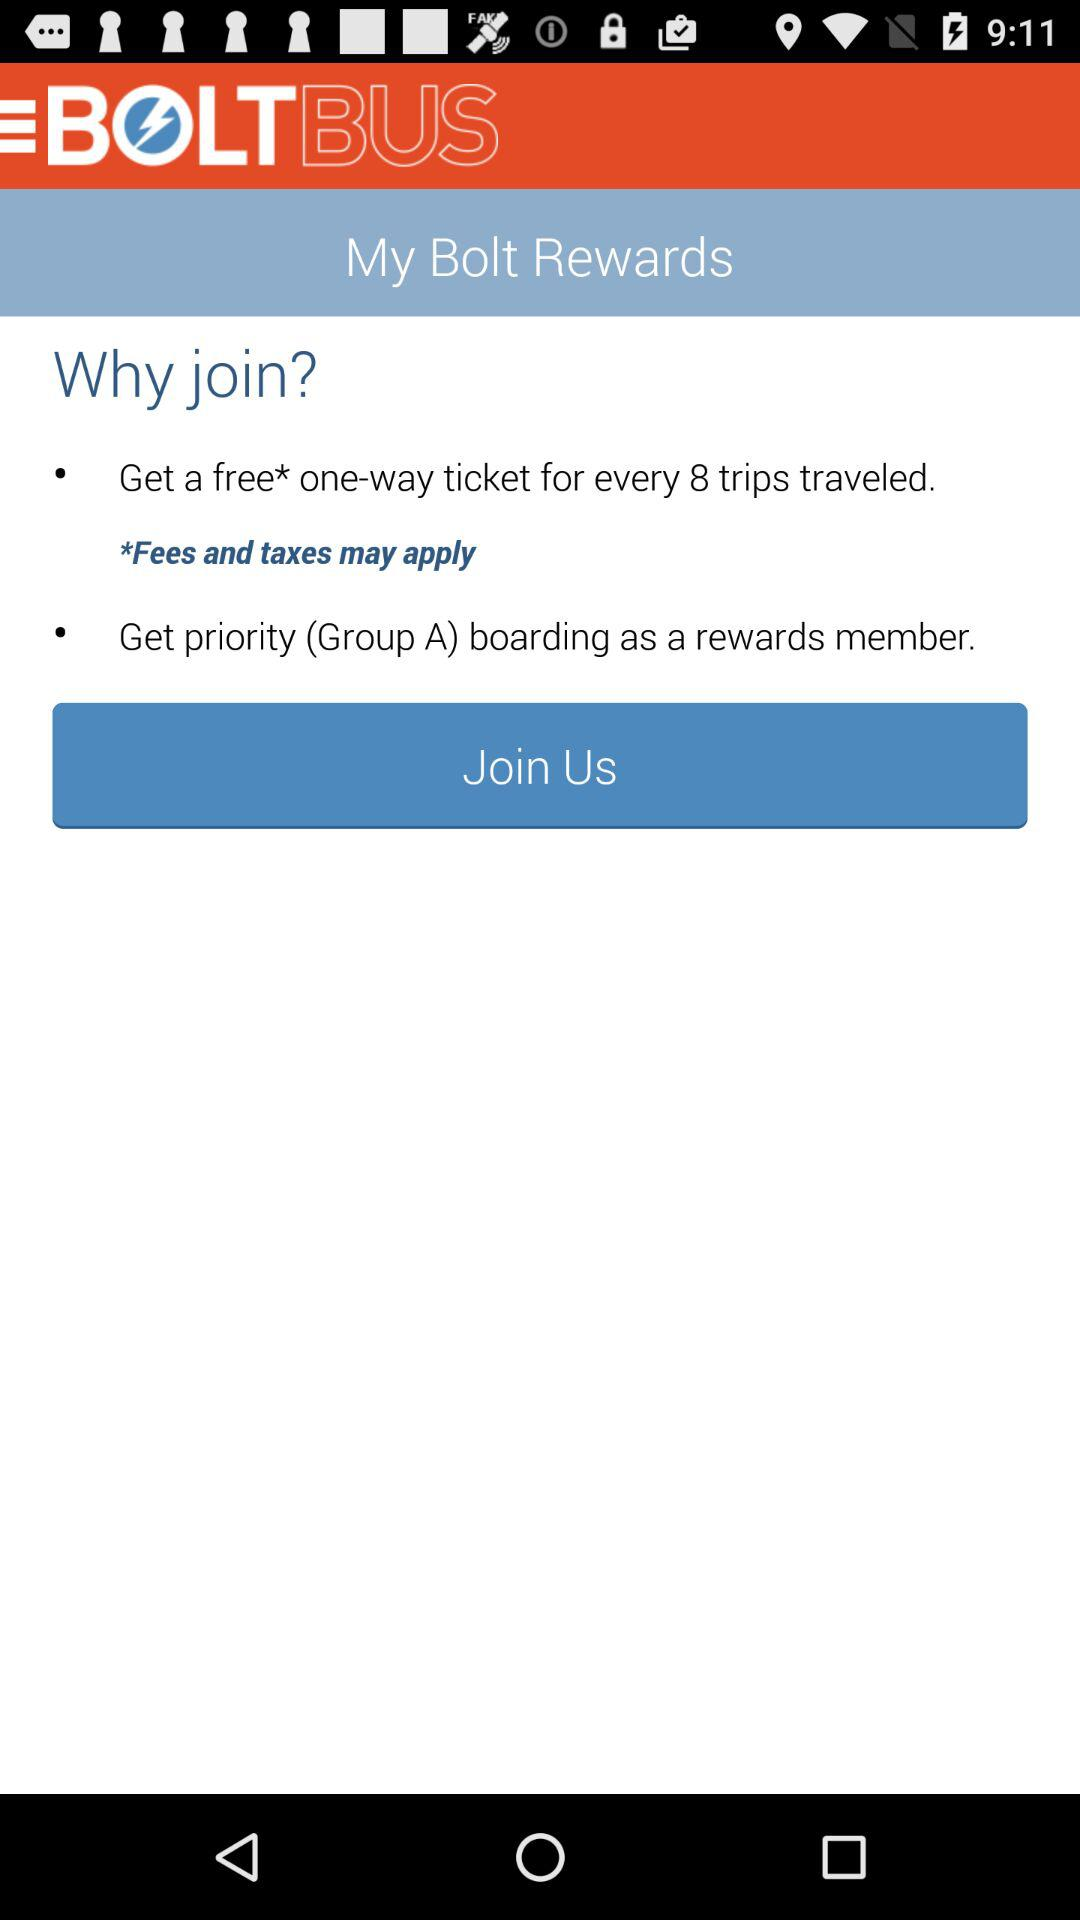How many benefits are there for joining the Bolt Rewards program?
Answer the question using a single word or phrase. 2 